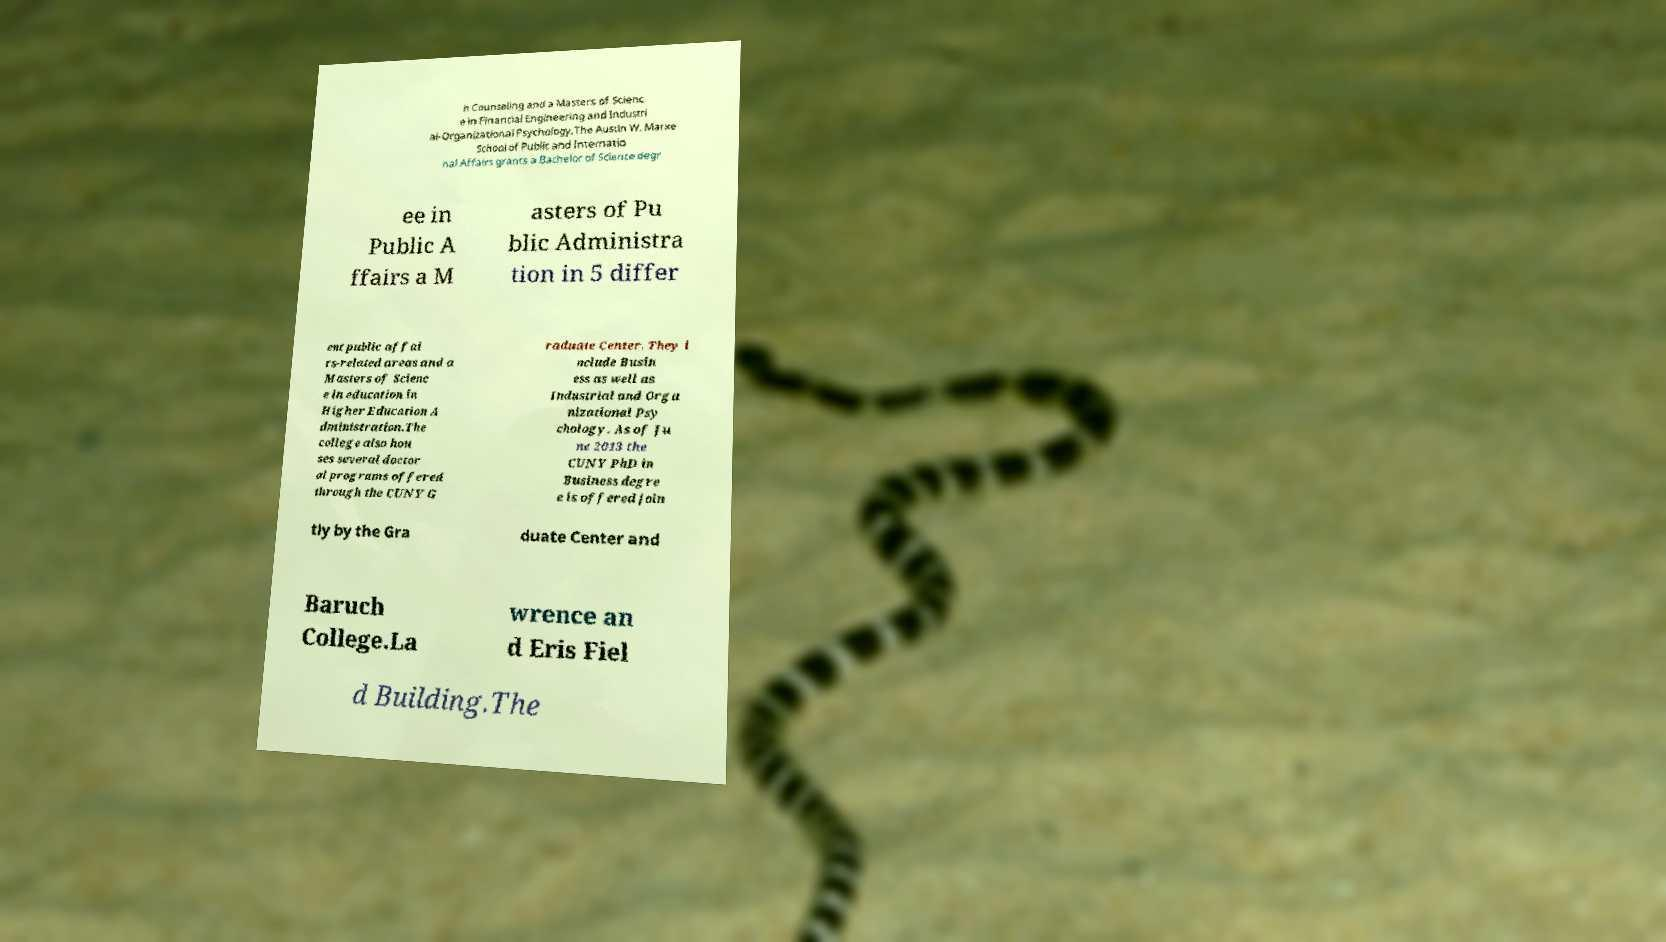Please read and relay the text visible in this image. What does it say? h Counseling and a Masters of Scienc e in Financial Engineering and Industri al-Organizational Psychology.The Austin W. Marxe School of Public and Internatio nal Affairs grants a Bachelor of Science degr ee in Public A ffairs a M asters of Pu blic Administra tion in 5 differ ent public affai rs-related areas and a Masters of Scienc e in education in Higher Education A dministration.The college also hou ses several doctor al programs offered through the CUNY G raduate Center. They i nclude Busin ess as well as Industrial and Orga nizational Psy chology. As of Ju ne 2013 the CUNY PhD in Business degre e is offered join tly by the Gra duate Center and Baruch College.La wrence an d Eris Fiel d Building.The 